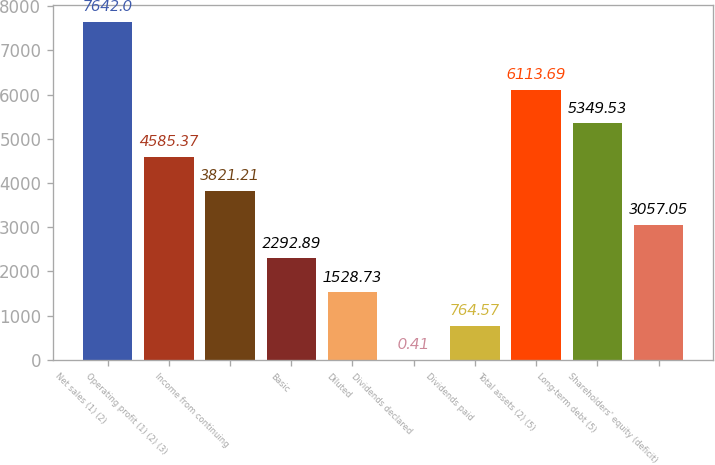<chart> <loc_0><loc_0><loc_500><loc_500><bar_chart><fcel>Net sales (1) (2)<fcel>Operating profit (1) (2) (3)<fcel>Income from continuing<fcel>Basic<fcel>Diluted<fcel>Dividends declared<fcel>Dividends paid<fcel>Total assets (2) (5)<fcel>Long-term debt (5)<fcel>Shareholders' equity (deficit)<nl><fcel>7642<fcel>4585.37<fcel>3821.21<fcel>2292.89<fcel>1528.73<fcel>0.41<fcel>764.57<fcel>6113.69<fcel>5349.53<fcel>3057.05<nl></chart> 